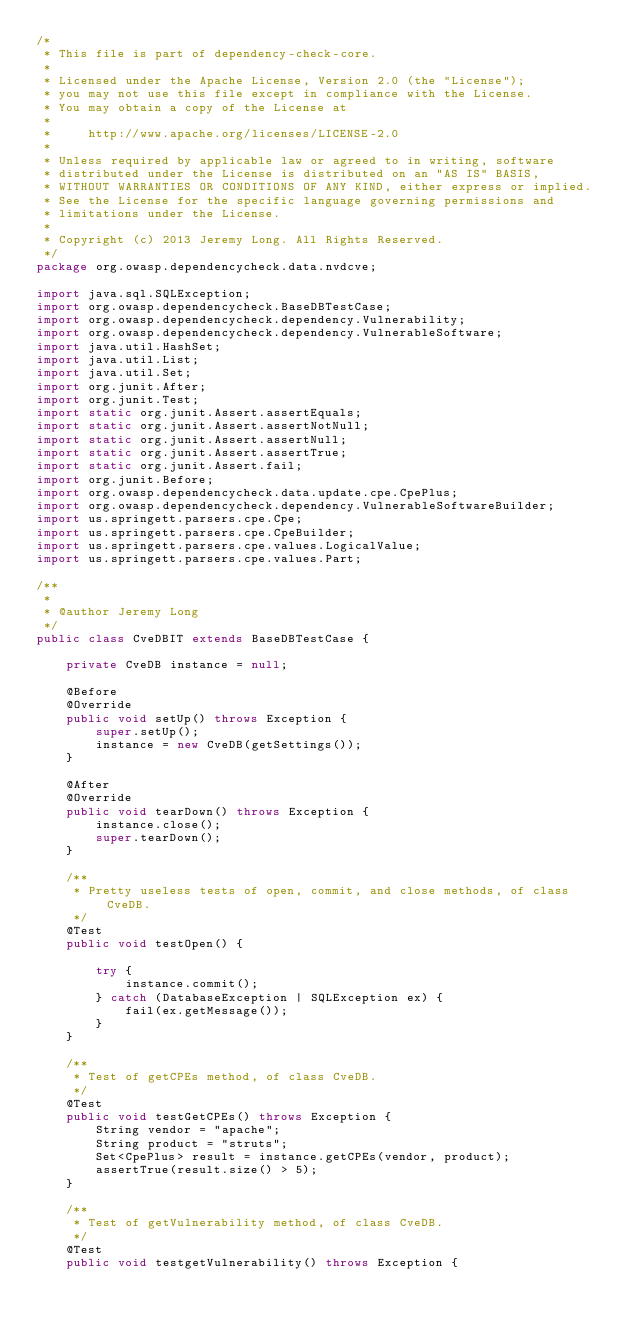<code> <loc_0><loc_0><loc_500><loc_500><_Java_>/*
 * This file is part of dependency-check-core.
 *
 * Licensed under the Apache License, Version 2.0 (the "License");
 * you may not use this file except in compliance with the License.
 * You may obtain a copy of the License at
 *
 *     http://www.apache.org/licenses/LICENSE-2.0
 *
 * Unless required by applicable law or agreed to in writing, software
 * distributed under the License is distributed on an "AS IS" BASIS,
 * WITHOUT WARRANTIES OR CONDITIONS OF ANY KIND, either express or implied.
 * See the License for the specific language governing permissions and
 * limitations under the License.
 *
 * Copyright (c) 2013 Jeremy Long. All Rights Reserved.
 */
package org.owasp.dependencycheck.data.nvdcve;

import java.sql.SQLException;
import org.owasp.dependencycheck.BaseDBTestCase;
import org.owasp.dependencycheck.dependency.Vulnerability;
import org.owasp.dependencycheck.dependency.VulnerableSoftware;
import java.util.HashSet;
import java.util.List;
import java.util.Set;
import org.junit.After;
import org.junit.Test;
import static org.junit.Assert.assertEquals;
import static org.junit.Assert.assertNotNull;
import static org.junit.Assert.assertNull;
import static org.junit.Assert.assertTrue;
import static org.junit.Assert.fail;
import org.junit.Before;
import org.owasp.dependencycheck.data.update.cpe.CpePlus;
import org.owasp.dependencycheck.dependency.VulnerableSoftwareBuilder;
import us.springett.parsers.cpe.Cpe;
import us.springett.parsers.cpe.CpeBuilder;
import us.springett.parsers.cpe.values.LogicalValue;
import us.springett.parsers.cpe.values.Part;

/**
 *
 * @author Jeremy Long
 */
public class CveDBIT extends BaseDBTestCase {

    private CveDB instance = null;

    @Before
    @Override
    public void setUp() throws Exception {
        super.setUp();
        instance = new CveDB(getSettings());
    }

    @After
    @Override
    public void tearDown() throws Exception {
        instance.close();
        super.tearDown();
    }

    /**
     * Pretty useless tests of open, commit, and close methods, of class CveDB.
     */
    @Test
    public void testOpen() {

        try {
            instance.commit();
        } catch (DatabaseException | SQLException ex) {
            fail(ex.getMessage());
        }
    }

    /**
     * Test of getCPEs method, of class CveDB.
     */
    @Test
    public void testGetCPEs() throws Exception {
        String vendor = "apache";
        String product = "struts";
        Set<CpePlus> result = instance.getCPEs(vendor, product);
        assertTrue(result.size() > 5);
    }

    /**
     * Test of getVulnerability method, of class CveDB.
     */
    @Test
    public void testgetVulnerability() throws Exception {</code> 